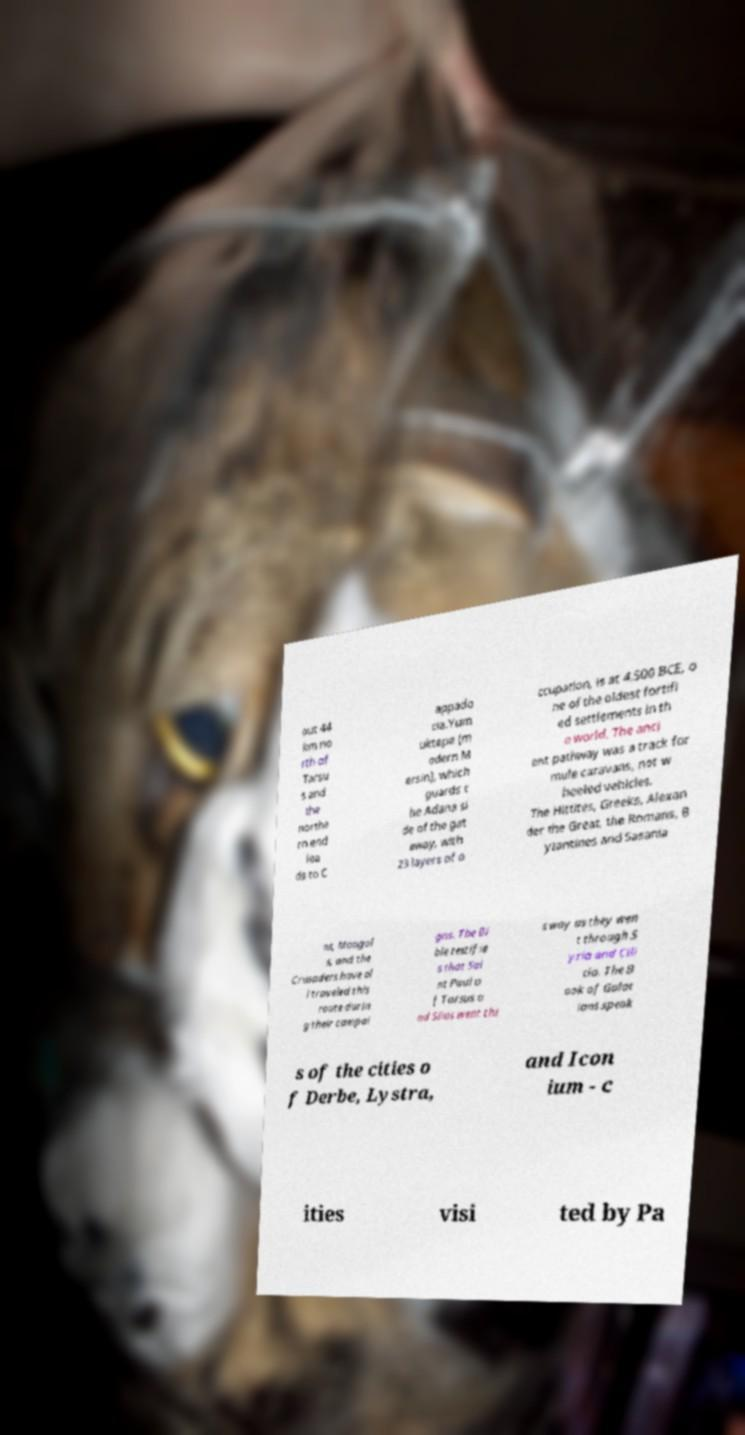Please read and relay the text visible in this image. What does it say? out 44 km no rth of Tarsu s and the northe rn end lea ds to C appado cia.Yum uktepe (m odern M ersin), which guards t he Adana si de of the gat eway, with 23 layers of o ccupation, is at 4,500 BCE, o ne of the oldest fortifi ed settlements in th e world. The anci ent pathway was a track for mule caravans, not w heeled vehicles. The Hittites, Greeks, Alexan der the Great, the Romans, B yzantines and Sasania ns, Mongol s, and the Crusaders have al l traveled this route durin g their campai gns. The Bi ble testifie s that Sai nt Paul o f Tarsus a nd Silas went thi s way as they wen t through S yria and Cili cia. The B ook of Galat ians speak s of the cities o f Derbe, Lystra, and Icon ium - c ities visi ted by Pa 